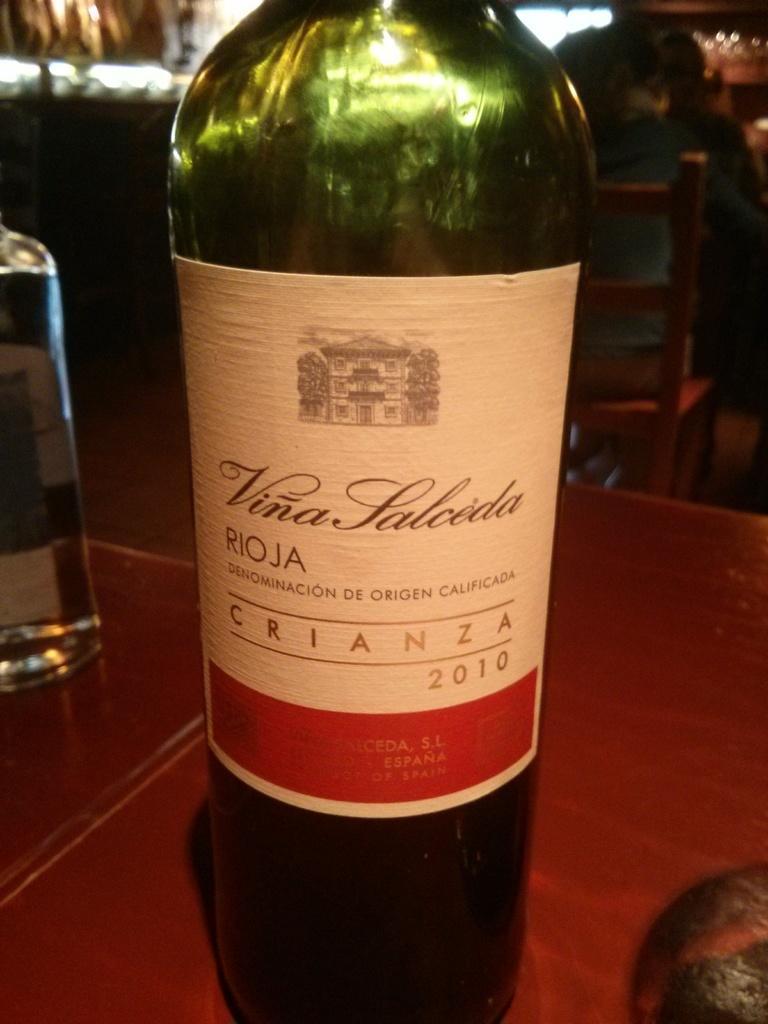Can you describe this image briefly? In this picture there is a bottle on the table. To the left , there is also another bottle on the table. To the right ,there is a person sitting on the chair. There is also another person to be right. 